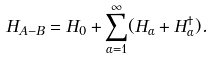Convert formula to latex. <formula><loc_0><loc_0><loc_500><loc_500>H _ { A - B } = H _ { 0 } + \sum _ { \alpha = 1 } ^ { \infty } ( H _ { \alpha } + H _ { \alpha } ^ { \dagger } ) .</formula> 